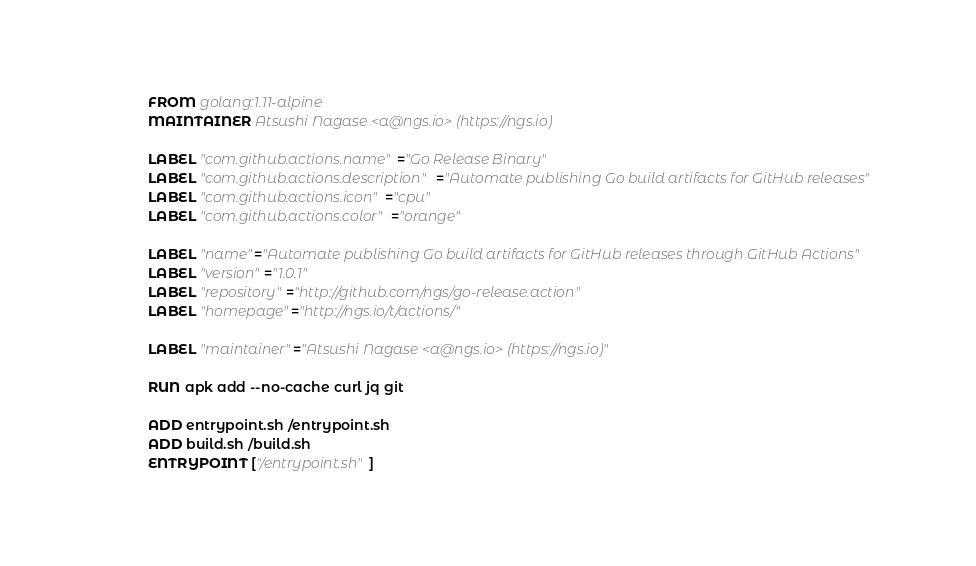<code> <loc_0><loc_0><loc_500><loc_500><_Dockerfile_>FROM golang:1.11-alpine
MAINTAINER Atsushi Nagase <a@ngs.io> (https://ngs.io)

LABEL "com.github.actions.name"="Go Release Binary"
LABEL "com.github.actions.description"="Automate publishing Go build artifacts for GitHub releases"
LABEL "com.github.actions.icon"="cpu"
LABEL "com.github.actions.color"="orange"

LABEL "name"="Automate publishing Go build artifacts for GitHub releases through GitHub Actions"
LABEL "version"="1.0.1"
LABEL "repository"="http://github.com/ngs/go-release.action"
LABEL "homepage"="http://ngs.io/t/actions/"

LABEL "maintainer"="Atsushi Nagase <a@ngs.io> (https://ngs.io)"

RUN apk add --no-cache curl jq git

ADD entrypoint.sh /entrypoint.sh
ADD build.sh /build.sh
ENTRYPOINT ["/entrypoint.sh"]
</code> 